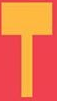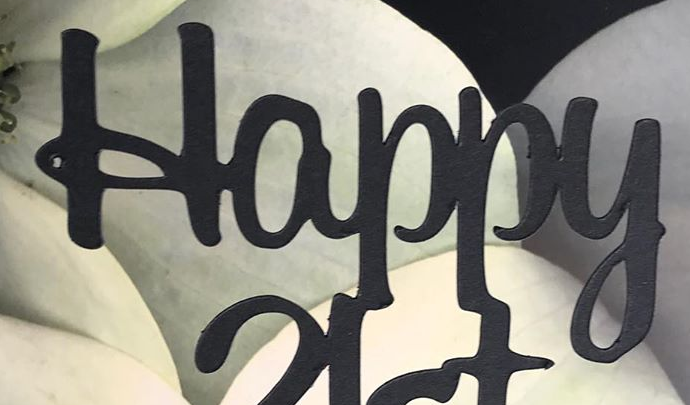What text is displayed in these images sequentially, separated by a semicolon? T; Happy 